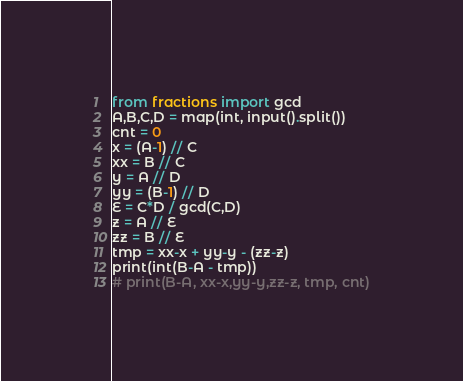<code> <loc_0><loc_0><loc_500><loc_500><_Python_>from fractions import gcd
A,B,C,D = map(int, input().split())
cnt = 0
x = (A-1) // C
xx = B // C
y = A // D
yy = (B-1) // D
E = C*D / gcd(C,D)
z = A // E
zz = B // E
tmp = xx-x + yy-y - (zz-z)
print(int(B-A - tmp))
# print(B-A, xx-x,yy-y,zz-z, tmp, cnt)</code> 